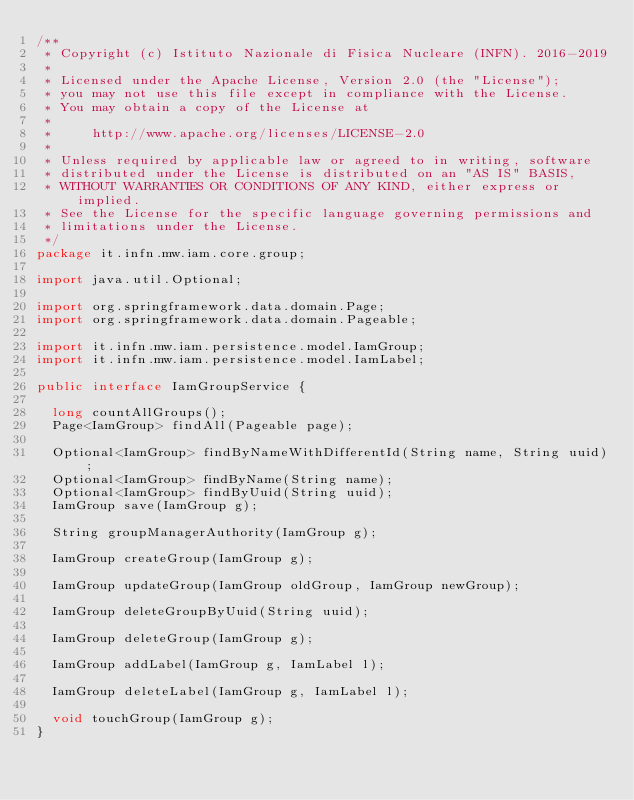<code> <loc_0><loc_0><loc_500><loc_500><_Java_>/**
 * Copyright (c) Istituto Nazionale di Fisica Nucleare (INFN). 2016-2019
 *
 * Licensed under the Apache License, Version 2.0 (the "License");
 * you may not use this file except in compliance with the License.
 * You may obtain a copy of the License at
 *
 *     http://www.apache.org/licenses/LICENSE-2.0
 *
 * Unless required by applicable law or agreed to in writing, software
 * distributed under the License is distributed on an "AS IS" BASIS,
 * WITHOUT WARRANTIES OR CONDITIONS OF ANY KIND, either express or implied.
 * See the License for the specific language governing permissions and
 * limitations under the License.
 */
package it.infn.mw.iam.core.group;

import java.util.Optional;

import org.springframework.data.domain.Page;
import org.springframework.data.domain.Pageable;

import it.infn.mw.iam.persistence.model.IamGroup;
import it.infn.mw.iam.persistence.model.IamLabel;

public interface IamGroupService {
  
  long countAllGroups();
  Page<IamGroup> findAll(Pageable page);
  
  Optional<IamGroup> findByNameWithDifferentId(String name, String uuid);
  Optional<IamGroup> findByName(String name);
  Optional<IamGroup> findByUuid(String uuid);
  IamGroup save(IamGroup g);
  
  String groupManagerAuthority(IamGroup g);
  
  IamGroup createGroup(IamGroup g);
  
  IamGroup updateGroup(IamGroup oldGroup, IamGroup newGroup);
  
  IamGroup deleteGroupByUuid(String uuid);
  
  IamGroup deleteGroup(IamGroup g);
  
  IamGroup addLabel(IamGroup g, IamLabel l);
  
  IamGroup deleteLabel(IamGroup g, IamLabel l);

  void touchGroup(IamGroup g);
}
</code> 